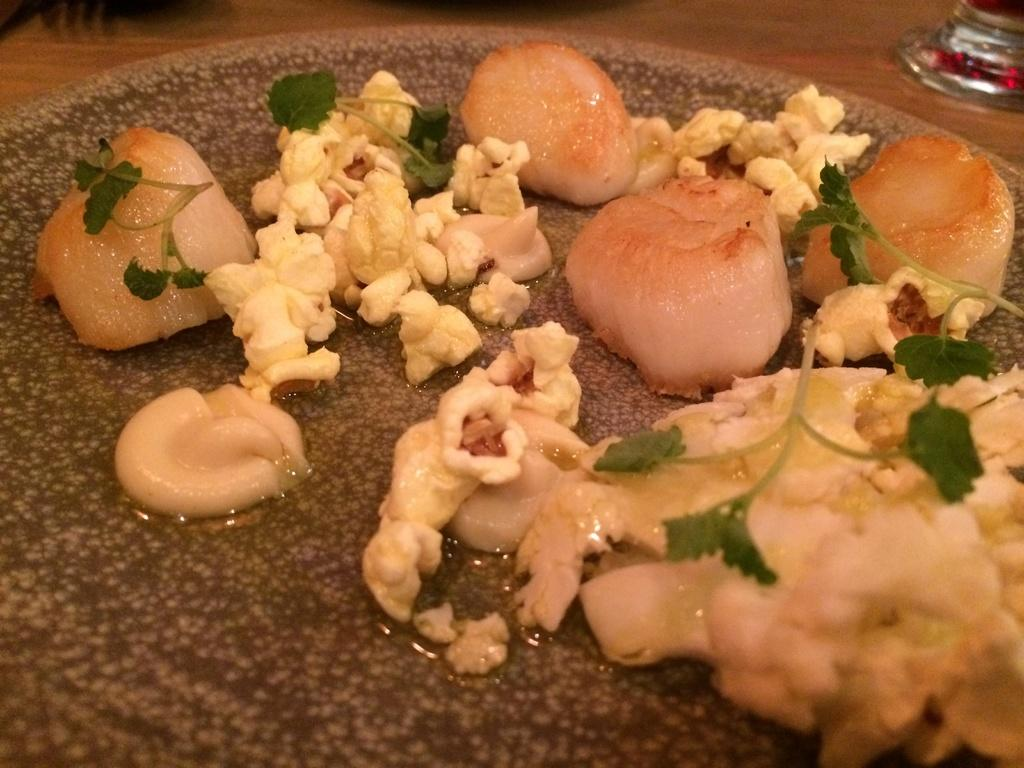What is being cooked in the pan in the image? There are meat pieces, leaves, and popcorn in a pan in the image. What is present in the pan along with the food items? There is oil in the pan. Can you describe the object in the background of the image? Unfortunately, the facts provided do not give any details about the object in the background. What type of cave can be seen in the background of the image? There is no cave present in the image. Can you tell me how many tigers are visible in the image? There are no tigers present in the image. 